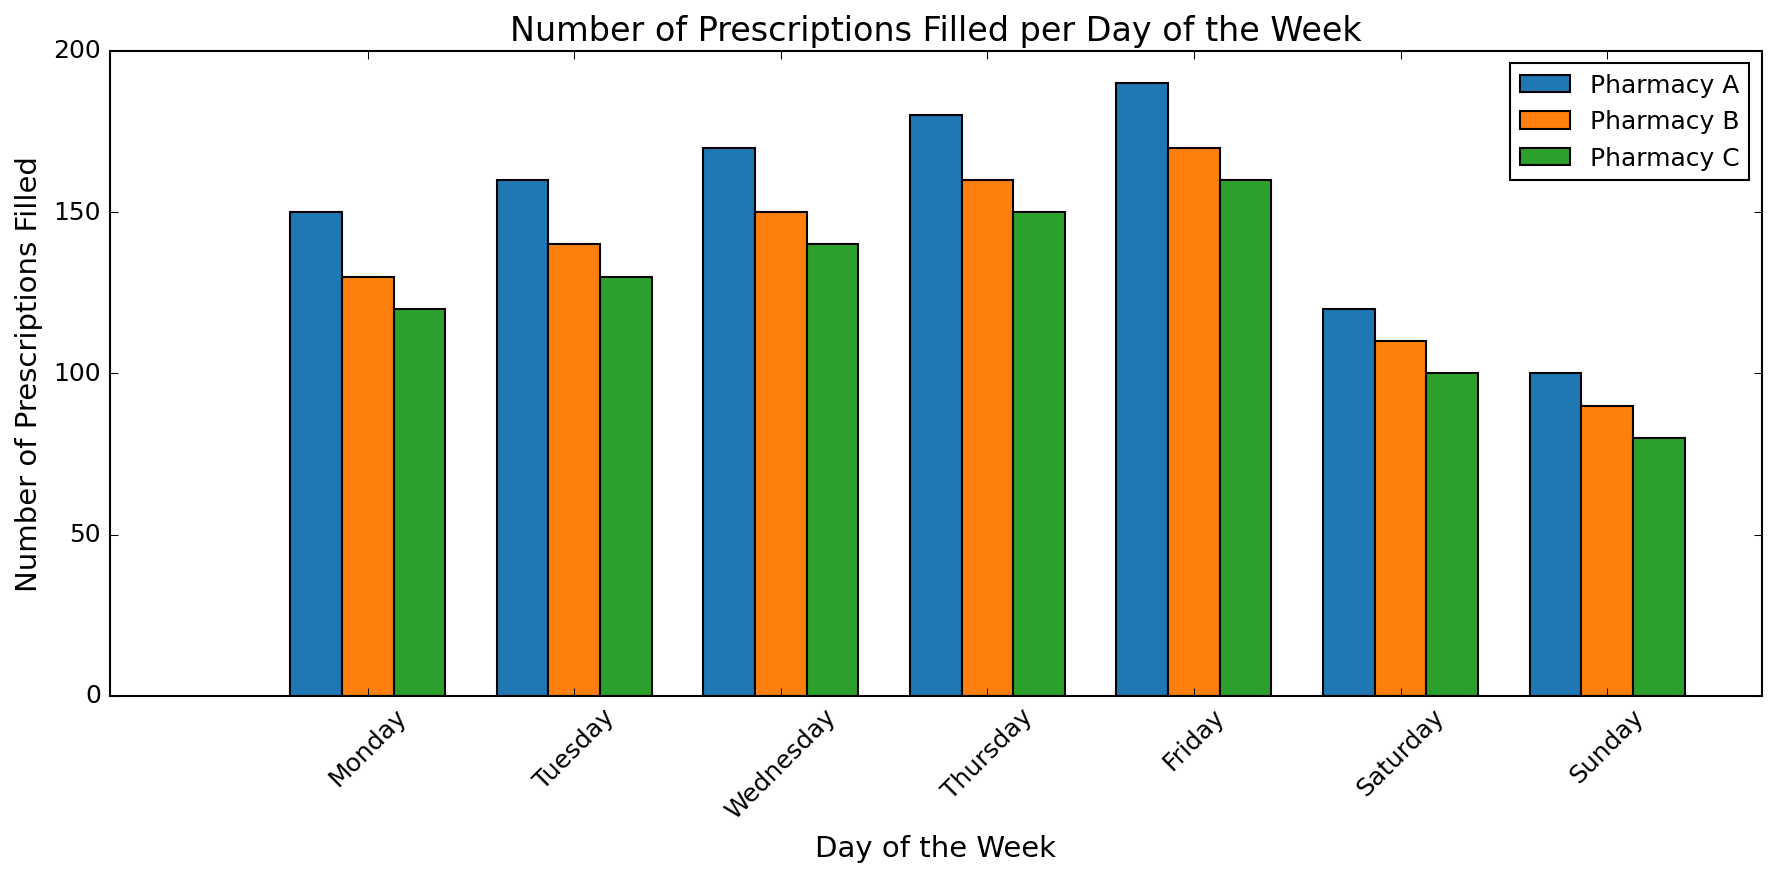Which pharmacy fills the most prescriptions on Friday? First, locate the bars for Friday on the x-axis. Observe the heights of the bars representing Pharmacy A, B, and C, and compare them. The tallest bar corresponds to Pharmacy A.
Answer: Pharmacy A How many more prescriptions does Pharmacy A fill on Sunday compared to Pharmacy B? Identify the bars for Sunday for both Pharmacy A and Pharmacy B. Note the values: Pharmacy A fills 100 prescriptions and Pharmacy B fills 90 prescriptions. Subtract the value for Pharmacy B from Pharmacy A (100 - 90).
Answer: 10 What is the average number of prescriptions filled by Pharmacy C from Monday to Wednesday? Locate the bars for Pharmacy C from Monday to Wednesday and note the values: 120, 130, and 140. Sum these values (120 + 130 + 140 = 390) and divide by the number of days (390 / 3).
Answer: 130 Which day has the highest total number of prescriptions filled across all pharmacies? For each day, sum the prescriptions for all pharmacies and compare the totals. Friday's values are 190 (A) + 170 (B) + 160 (C) = 520, and this is the highest total compared to other days.
Answer: Friday Compare the total prescriptions filled by Pharmacy B and Pharmacy C on weekends (Saturday and Sunday). Which pharmacy fills more? Calculate the sum for Pharmacy B on Saturday and Sunday (110 + 90 = 200) and for Pharmacy C (100 + 80 = 180). Compare these sums to determine which is higher.
Answer: Pharmacy B What is the total number of prescriptions filled by Pharmacy A over the entire week? Note the values for Pharmacy A for each day: 150, 160, 170, 180, 190, 120, and 100. Sum these values (150 + 160 + 170 + 180 + 190 + 120 + 100 = 1070).
Answer: 1070 On which day does Pharmacy C fill the fewest prescriptions? Observe the heights of the bars for Pharmacy C for each day and find the shortest bar. The shortest bar is on Sunday.
Answer: Sunday How many prescriptions does Pharmacy B fill on average per day? Note the values for Pharmacy B for each day: 130, 140, 150, 160, 170, 110, 90. Sum these values (130 + 140 + 150 + 160 + 170 + 110 + 90 = 950) and divide by the number of days (950 / 7).
Answer: 135.71 Compare the prescriptions filled by Pharmacy A and C on Thursday, and determine the difference. Identify the bars for Thursday for both pharmacies: Pharmacy A fills 180 prescriptions, and Pharmacy C fills 150 prescriptions. Subtract the value for Pharmacy C from Pharmacy A (180 - 150).
Answer: 30 